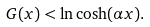Convert formula to latex. <formula><loc_0><loc_0><loc_500><loc_500>G ( x ) < \ln \cosh ( \alpha x ) .</formula> 